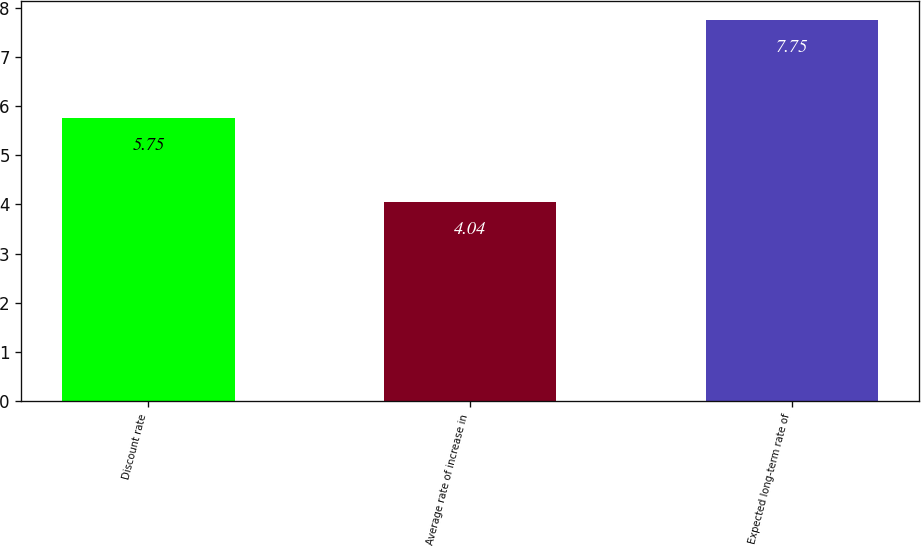Convert chart to OTSL. <chart><loc_0><loc_0><loc_500><loc_500><bar_chart><fcel>Discount rate<fcel>Average rate of increase in<fcel>Expected long-term rate of<nl><fcel>5.75<fcel>4.04<fcel>7.75<nl></chart> 